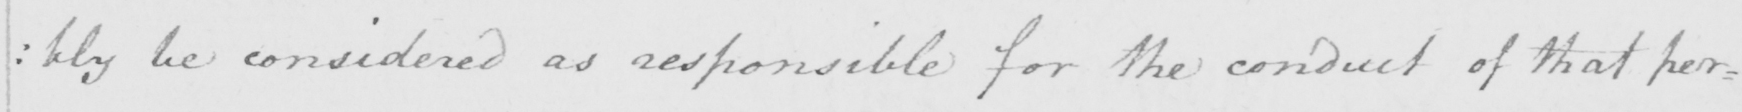What is written in this line of handwriting? : bly be considered as responsible for the conduct of that per= 